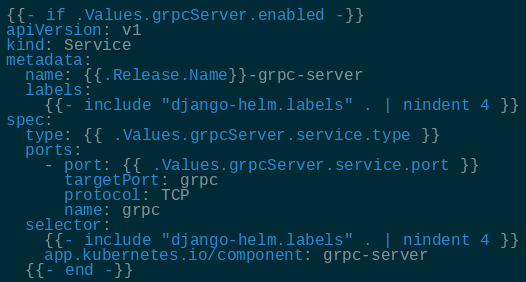Convert code to text. <code><loc_0><loc_0><loc_500><loc_500><_YAML_>{{- if .Values.grpcServer.enabled -}}
apiVersion: v1
kind: Service
metadata:
  name: {{.Release.Name}}-grpc-server
  labels:
    {{- include "django-helm.labels" . | nindent 4 }}
spec:
  type: {{ .Values.grpcServer.service.type }}
  ports:
    - port: {{ .Values.grpcServer.service.port }}
      targetPort: grpc
      protocol: TCP
      name: grpc
  selector:
    {{- include "django-helm.labels" . | nindent 4 }}
    app.kubernetes.io/component: grpc-server
  {{- end -}}</code> 